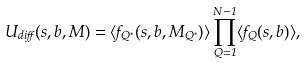<formula> <loc_0><loc_0><loc_500><loc_500>U _ { d i f f } ( s , b , M ) = \langle f _ { Q ^ { * } } ( s , b , M _ { Q ^ { * } } ) \rangle \prod ^ { N - 1 } _ { Q = 1 } \langle f _ { Q } ( s , b ) \rangle ,</formula> 